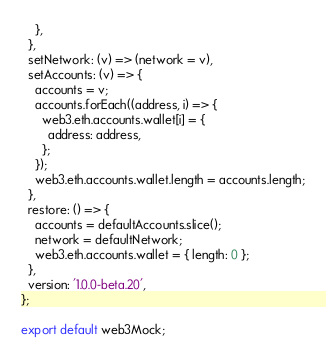Convert code to text. <code><loc_0><loc_0><loc_500><loc_500><_JavaScript_>    },
  },
  setNetwork: (v) => (network = v),
  setAccounts: (v) => {
    accounts = v;
    accounts.forEach((address, i) => {
      web3.eth.accounts.wallet[i] = {
        address: address,
      };
    });
    web3.eth.accounts.wallet.length = accounts.length;
  },
  restore: () => {
    accounts = defaultAccounts.slice();
    network = defaultNetwork;
    web3.eth.accounts.wallet = { length: 0 };
  },
  version: '1.0.0-beta.20',
};

export default web3Mock;
</code> 